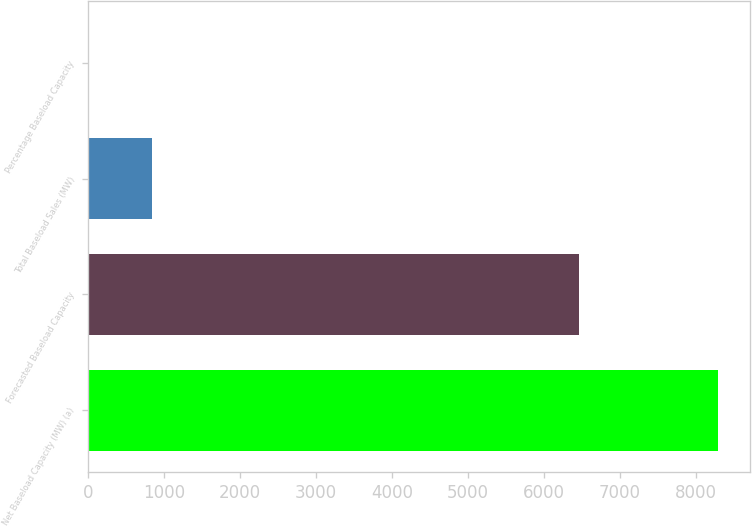Convert chart to OTSL. <chart><loc_0><loc_0><loc_500><loc_500><bar_chart><fcel>Net Baseload Capacity (MW) (a)<fcel>Forecasted Baseload Capacity<fcel>Total Baseload Sales (MW)<fcel>Percentage Baseload Capacity<nl><fcel>8295<fcel>6459<fcel>840.3<fcel>12<nl></chart> 